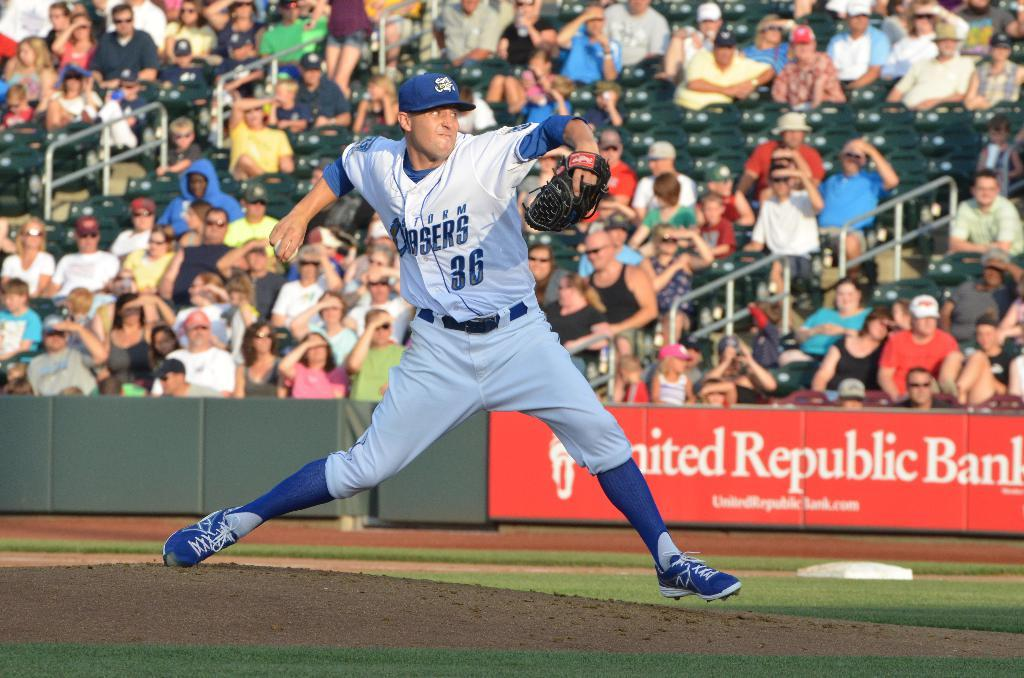<image>
Create a compact narrative representing the image presented. A player from the storm chasers team plays in front of the United Republic Bank banner. 